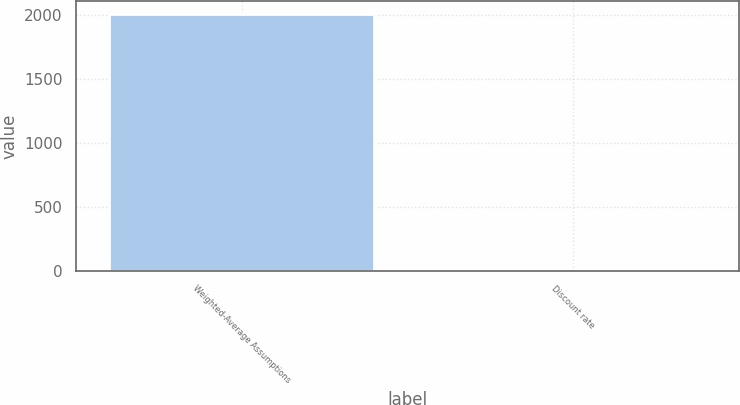Convert chart. <chart><loc_0><loc_0><loc_500><loc_500><bar_chart><fcel>Weighted-Average Assumptions<fcel>Discount rate<nl><fcel>2010<fcel>6.14<nl></chart> 